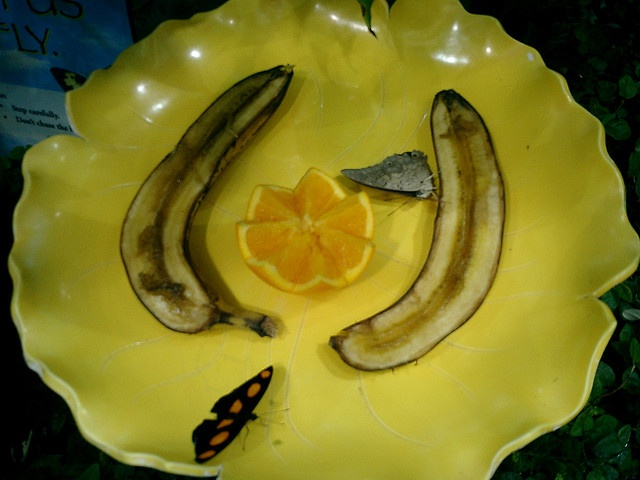Describe the objects in this image and their specific colors. I can see banana in navy, tan, and olive tones, banana in navy, olive, and black tones, and orange in navy, olive, and gold tones in this image. 